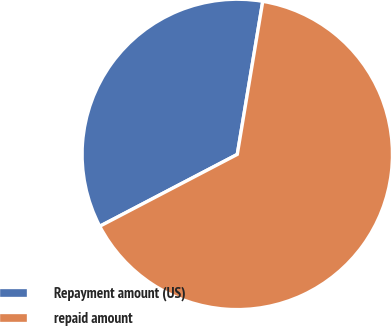Convert chart. <chart><loc_0><loc_0><loc_500><loc_500><pie_chart><fcel>Repayment amount (US)<fcel>repaid amount<nl><fcel>35.29%<fcel>64.71%<nl></chart> 